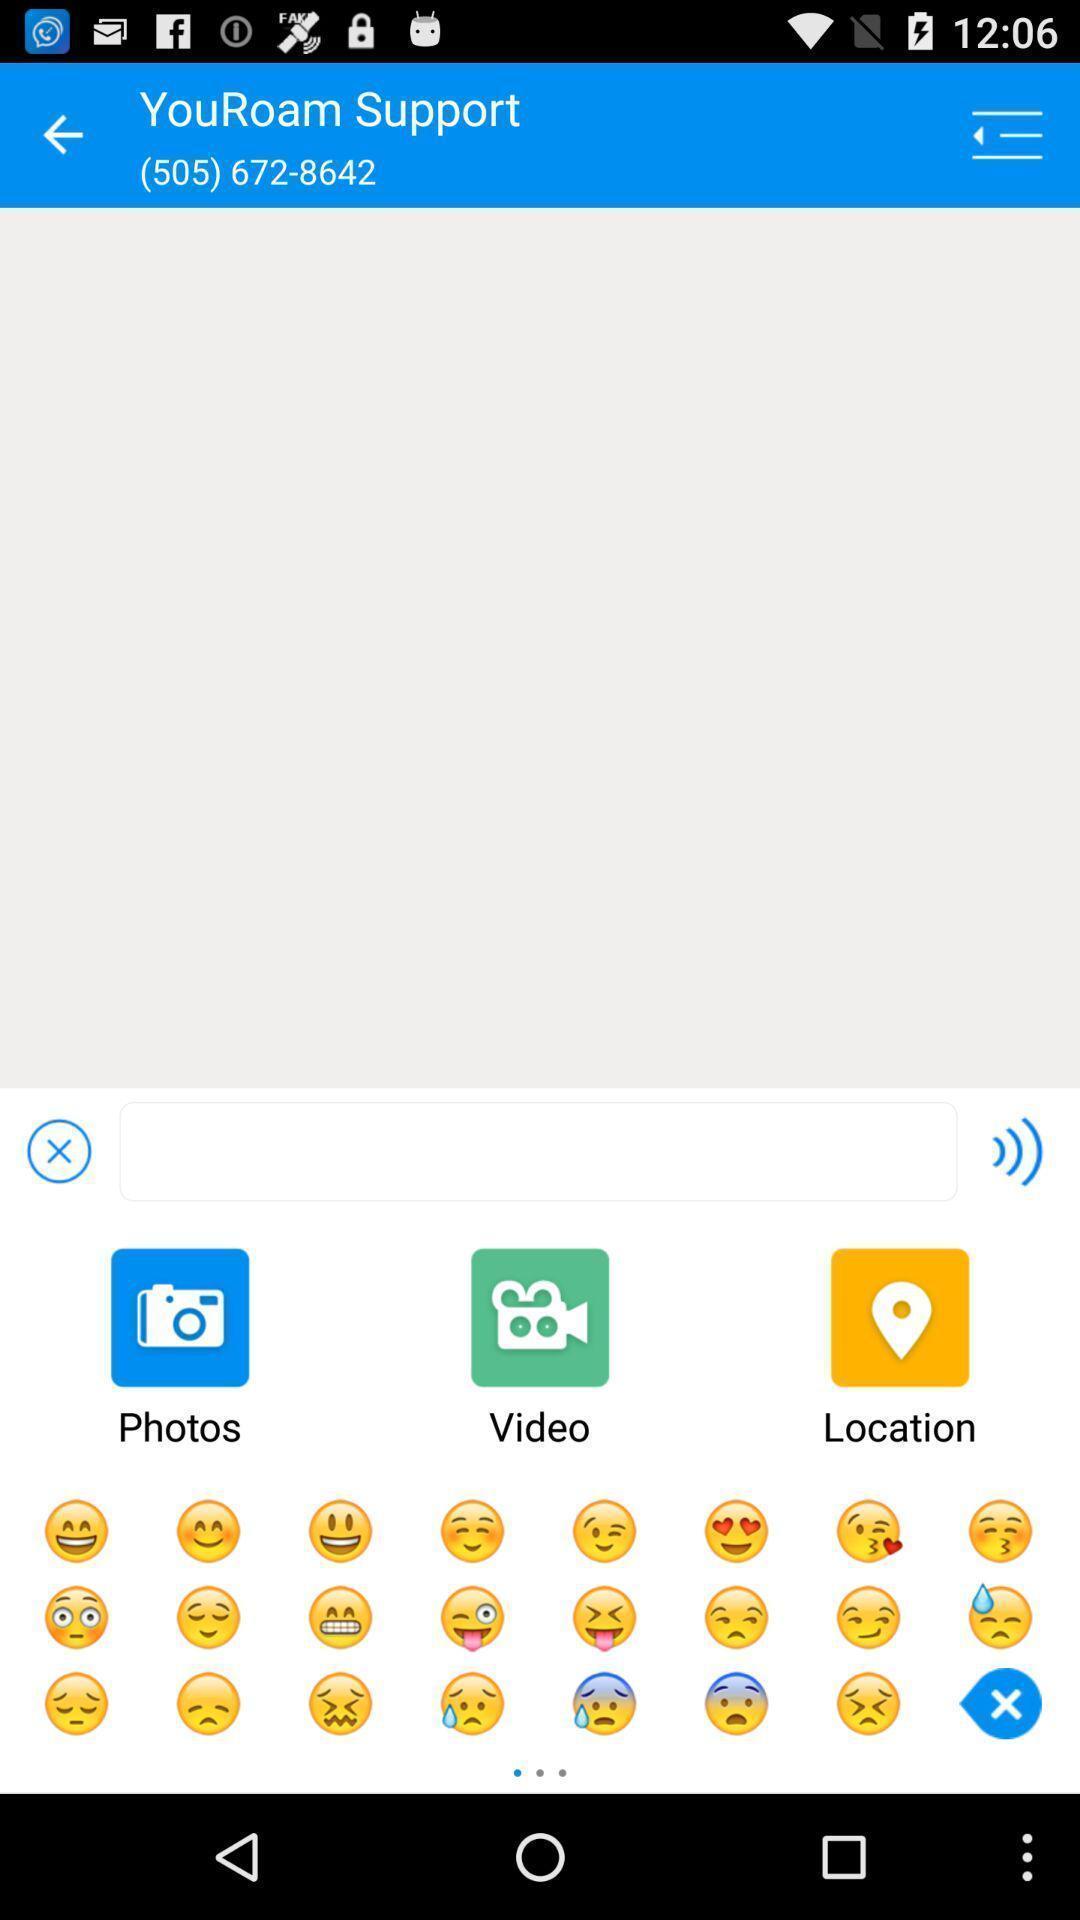Describe the visual elements of this screenshot. Texting bar and emojis for support. 